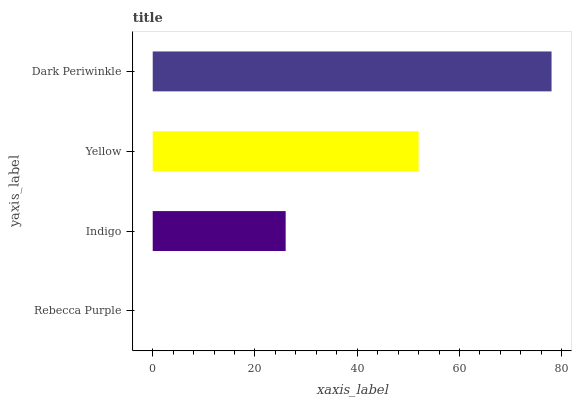Is Rebecca Purple the minimum?
Answer yes or no. Yes. Is Dark Periwinkle the maximum?
Answer yes or no. Yes. Is Indigo the minimum?
Answer yes or no. No. Is Indigo the maximum?
Answer yes or no. No. Is Indigo greater than Rebecca Purple?
Answer yes or no. Yes. Is Rebecca Purple less than Indigo?
Answer yes or no. Yes. Is Rebecca Purple greater than Indigo?
Answer yes or no. No. Is Indigo less than Rebecca Purple?
Answer yes or no. No. Is Yellow the high median?
Answer yes or no. Yes. Is Indigo the low median?
Answer yes or no. Yes. Is Indigo the high median?
Answer yes or no. No. Is Rebecca Purple the low median?
Answer yes or no. No. 